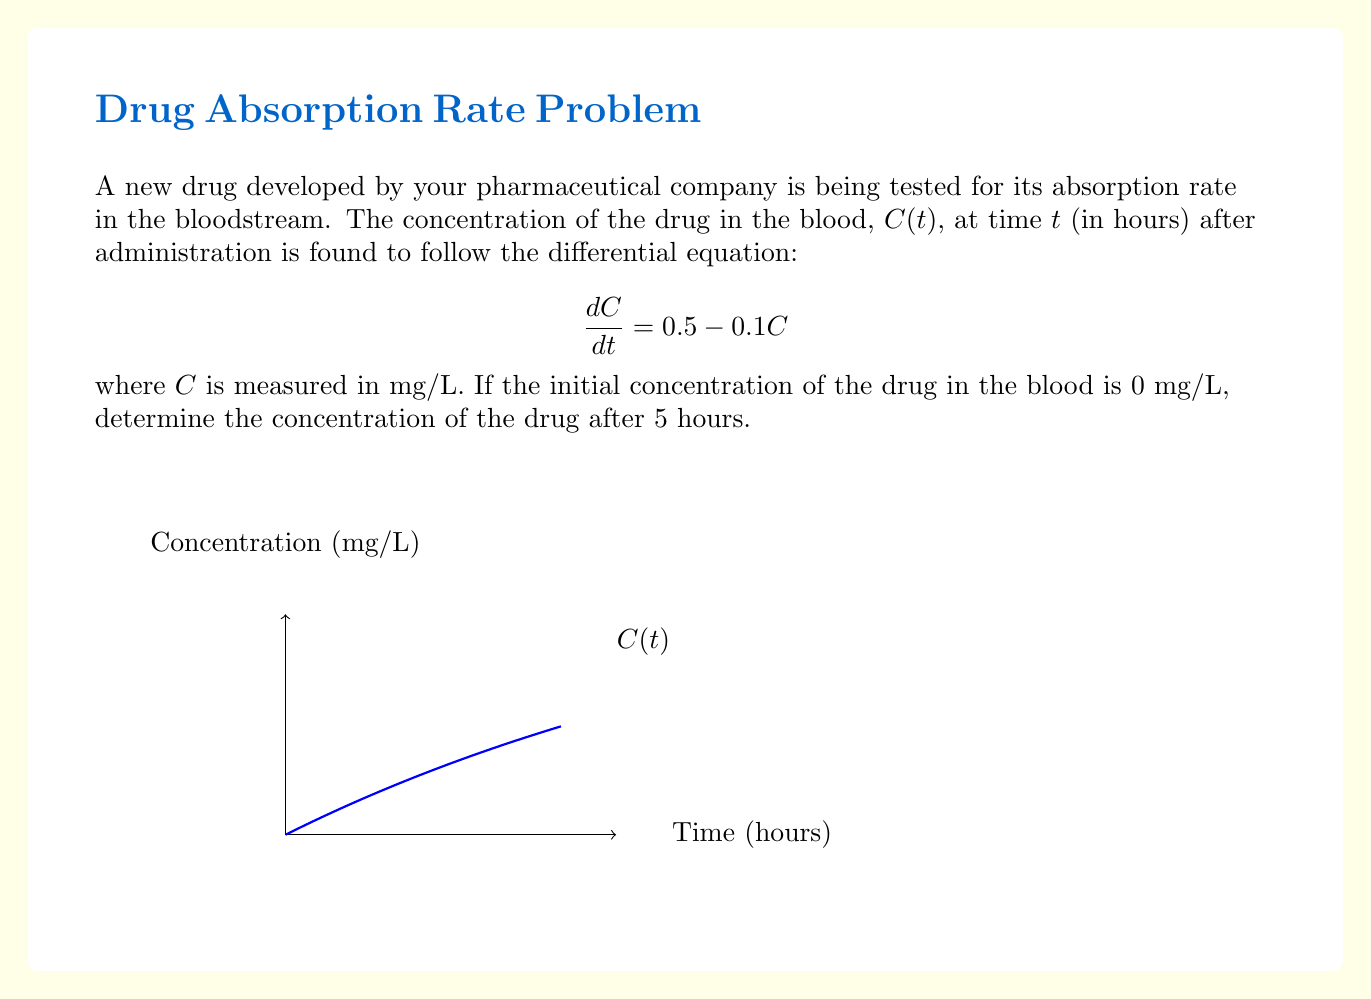Provide a solution to this math problem. Let's solve this problem step by step:

1) We have a first-order linear differential equation:
   $$\frac{dC}{dt} = 0.5 - 0.1C$$

2) This is in the standard form $\frac{dy}{dx} + P(x)y = Q(x)$, where:
   $P(x) = 0.1$ and $Q(x) = 0.5$

3) The general solution for this type of equation is:
   $$C(t) = e^{-\int P(t)dt} (\int Q(t)e^{\int P(t)dt}dt + K)$$

4) Solving the integrals:
   $\int P(t)dt = \int 0.1dt = 0.1t$
   $e^{\int P(t)dt} = e^{0.1t}$

5) Substituting into the general solution:
   $$C(t) = e^{-0.1t} (\int 0.5e^{0.1t}dt + K)$$

6) Solving the remaining integral:
   $$C(t) = e^{-0.1t} (5e^{0.1t} + K)$$

7) Simplifying:
   $$C(t) = 5 + Ke^{-0.1t}$$

8) Using the initial condition $C(0) = 0$:
   $$0 = 5 + K$$
   $$K = -5$$

9) Therefore, the particular solution is:
   $$C(t) = 5 - 5e^{-0.1t}$$

10) To find the concentration after 5 hours, we substitute $t = 5$:
    $$C(5) = 5 - 5e^{-0.1(5)} = 5 - 5e^{-0.5} \approx 3.03$$
Answer: $3.03$ mg/L 